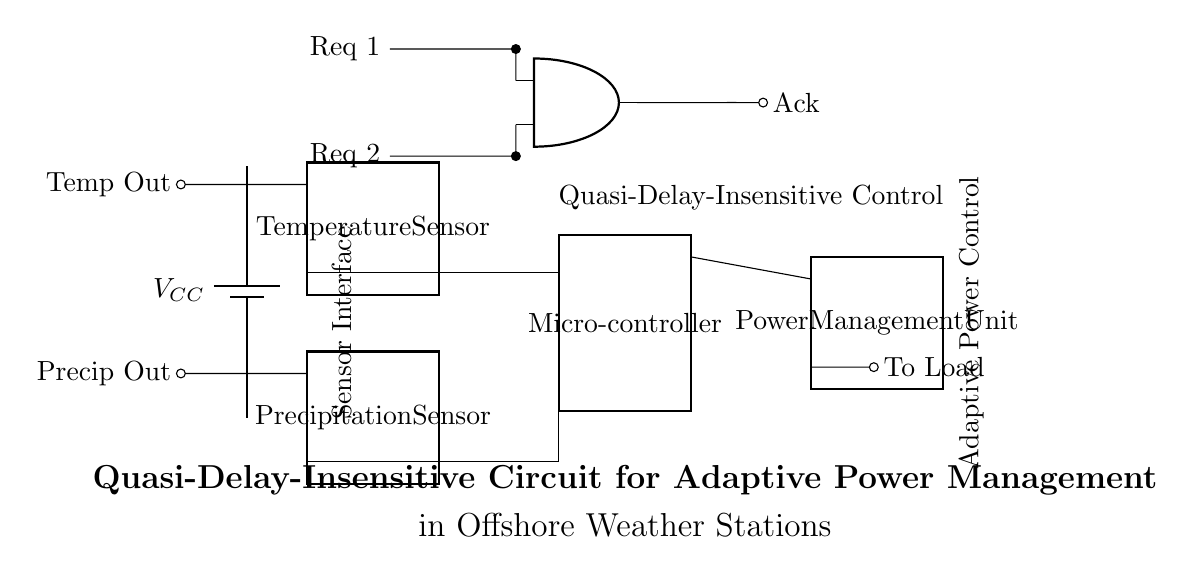What are the main components shown in the circuit? The circuit includes a temperature sensor, precipitation sensor, microcontroller, and power management unit, as indicated by their respective labels and symbols.
Answer: temperature sensor, precipitation sensor, microcontroller, power management unit What is the function of the Muller C-element in this circuit? The Muller C-element is used for asynchronous control, providing a way to synchronize signals without a global clock. Its functionality is indicated visually by its input and output connections.
Answer: asynchronous control What is the purpose of the power management unit? The power management unit is responsible for adjusting power distribution to the load based on inputs from the sensors and the microcontroller's processing. This purpose is evident from its placement and labeling in the circuit.
Answer: adjust power distribution How many pins are present on the microcontroller? The microcontroller is shown to have eight pins, which is indicated by the dipchip symbol annotated with the number of pins.
Answer: eight What type of circuit control is employed in this diagram? The diagram employs quasi-delay-insensitive control, as explicitly stated in the labeling within the circuit. This type of control enables operation without strict timing constraints.
Answer: quasi-delay-insensitive control Which sensors provide input to the microcontroller? The temperature sensor and precipitation sensor provide input to the microcontroller as they are connected to its designated input pins.
Answer: temperature sensor, precipitation sensor 